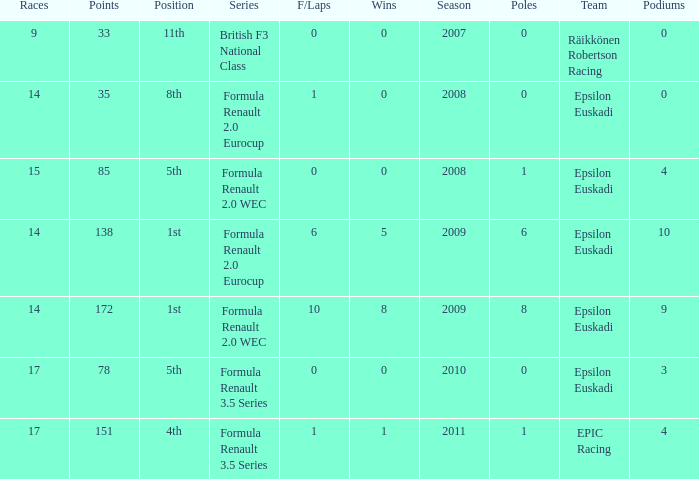How many podiums when he was in the british f3 national class series? 1.0. Write the full table. {'header': ['Races', 'Points', 'Position', 'Series', 'F/Laps', 'Wins', 'Season', 'Poles', 'Team', 'Podiums'], 'rows': [['9', '33', '11th', 'British F3 National Class', '0', '0', '2007', '0', 'Räikkönen Robertson Racing', '0'], ['14', '35', '8th', 'Formula Renault 2.0 Eurocup', '1', '0', '2008', '0', 'Epsilon Euskadi', '0'], ['15', '85', '5th', 'Formula Renault 2.0 WEC', '0', '0', '2008', '1', 'Epsilon Euskadi', '4'], ['14', '138', '1st', 'Formula Renault 2.0 Eurocup', '6', '5', '2009', '6', 'Epsilon Euskadi', '10'], ['14', '172', '1st', 'Formula Renault 2.0 WEC', '10', '8', '2009', '8', 'Epsilon Euskadi', '9'], ['17', '78', '5th', 'Formula Renault 3.5 Series', '0', '0', '2010', '0', 'Epsilon Euskadi', '3'], ['17', '151', '4th', 'Formula Renault 3.5 Series', '1', '1', '2011', '1', 'EPIC Racing', '4']]} 